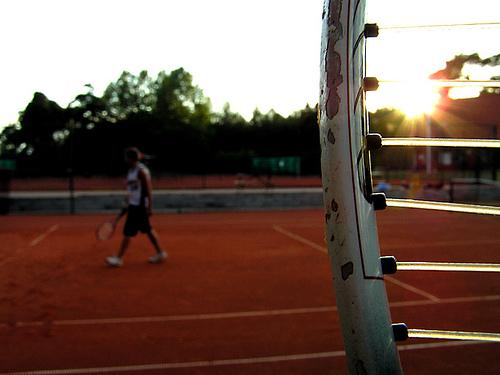What is partially blocking this image?

Choices:
A) fan
B) spokes
C) racket
D) tubing racket 